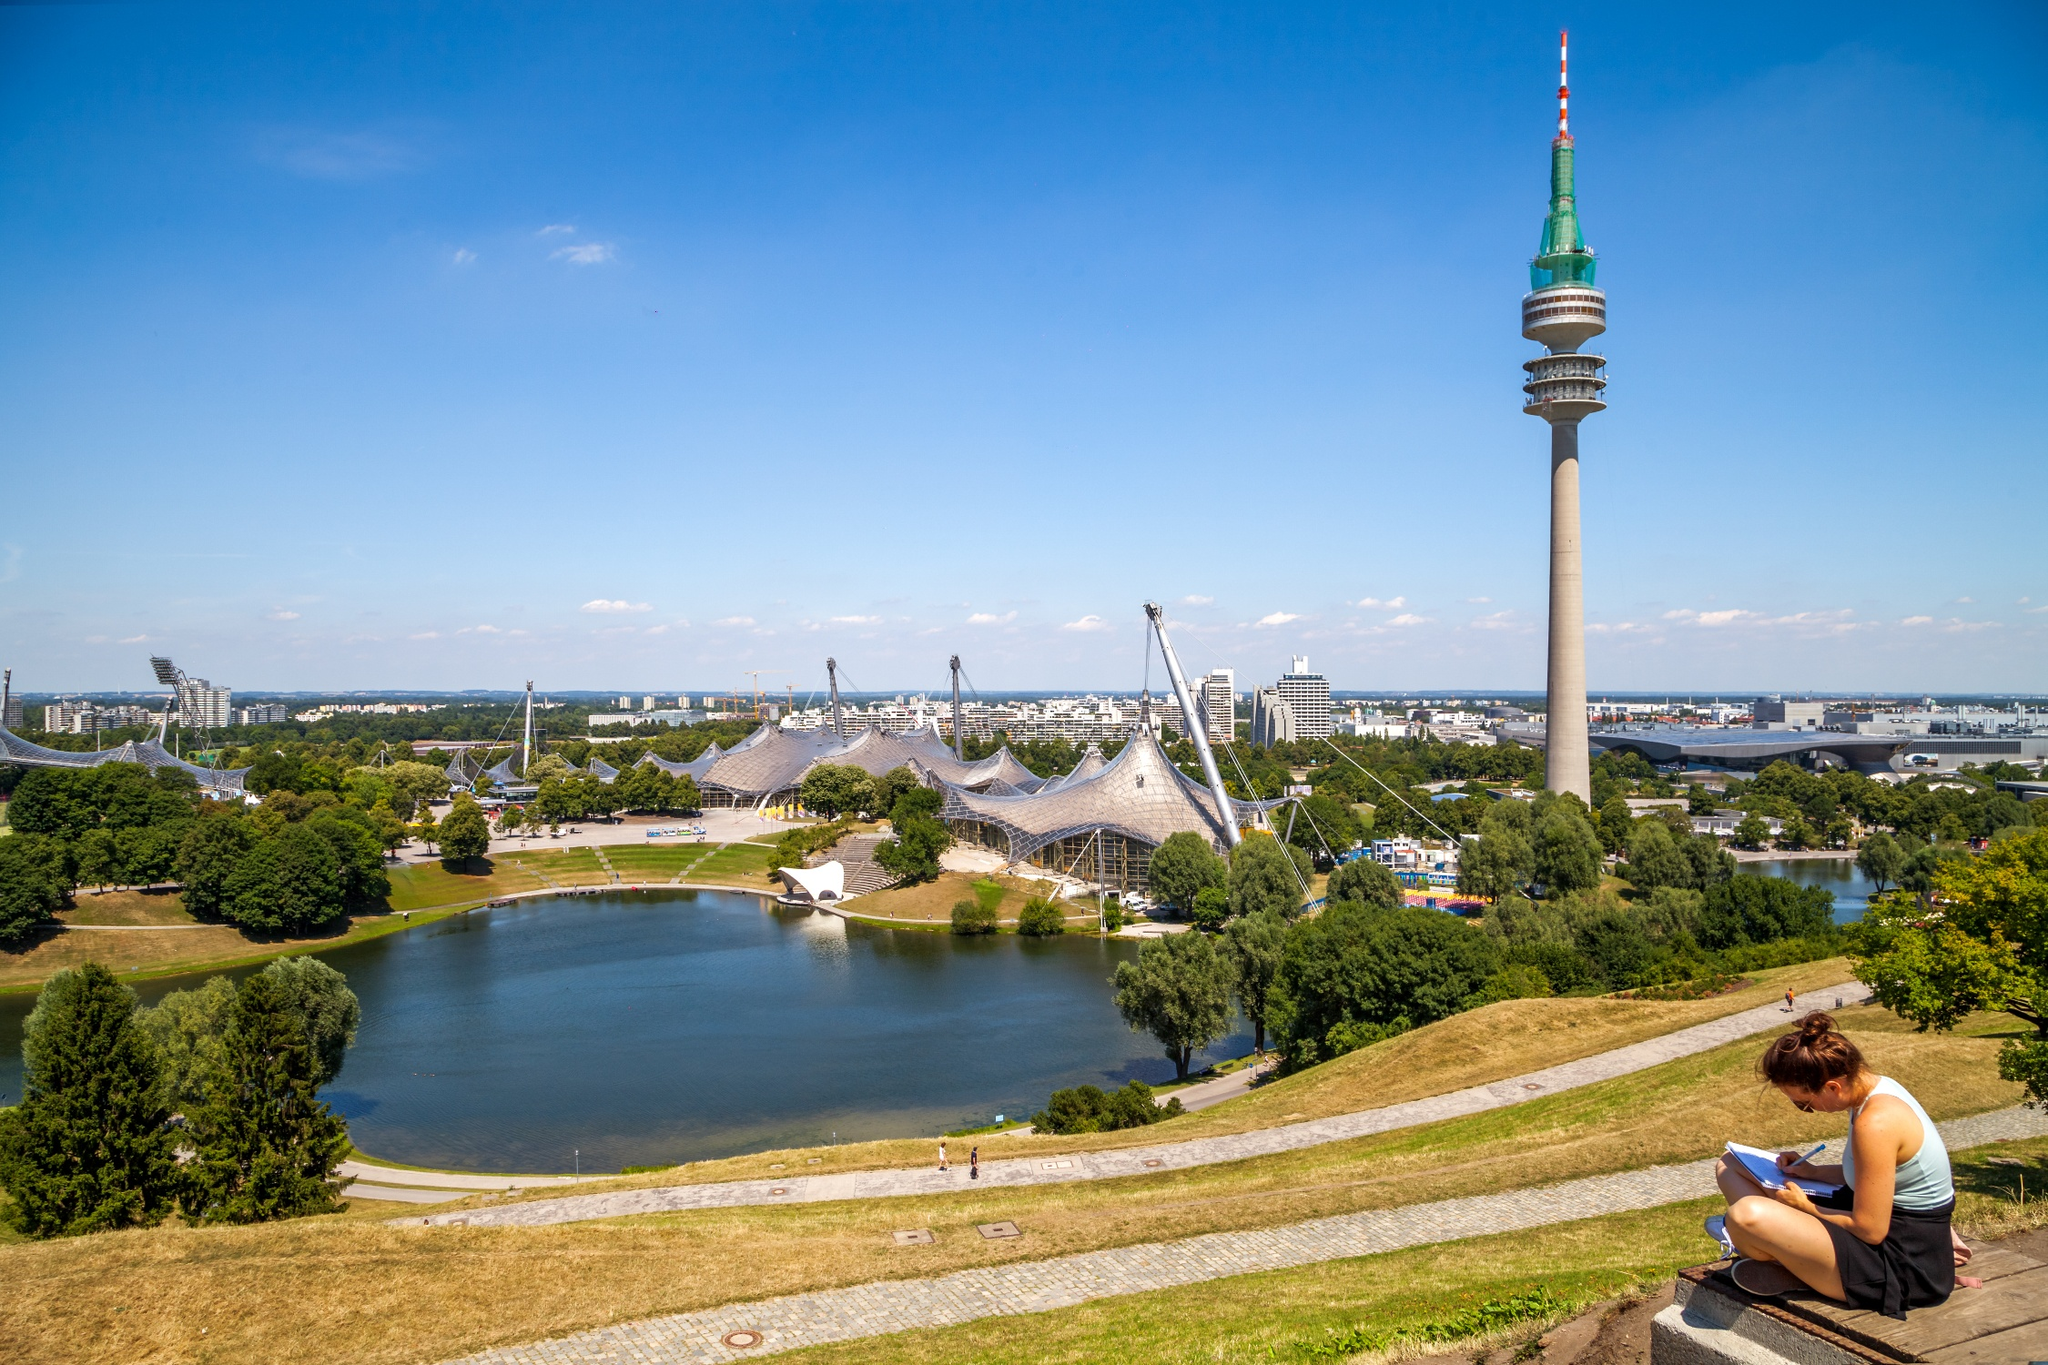What's special about the lake in this park? The lake in the Olympic Park, known as Olympic Lake, is a man-made lake that enhances the park's beauty and tranquility. It was created as part of the landscaping for the 1972 Olympics. The lake, with its serene waters, provides a peaceful environment for visitors to relax, take boat rides, or enjoy the scenic views. The presence of this lake adds to the aesthetic and ecological value of the park. How is the lake integrated into the park's ecosystem? The Olympic Lake is an integral part of the park's ecosystem, creating a rich habitat for various species of plants and animals. The water body helps maintain a balanced environment, offering a sanctuary for birds, fish, and other wildlife. It also plays a role in the park's drainage system, ensuring that the lush greenery remains well-nourished and the park's ecosystem stays vibrant and sustainable. 